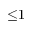<formula> <loc_0><loc_0><loc_500><loc_500>{ \leq } 1</formula> 